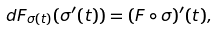Convert formula to latex. <formula><loc_0><loc_0><loc_500><loc_500>d F _ { \sigma ( t ) } ( \sigma ^ { \prime } ( t ) ) = ( F \circ \sigma ) ^ { \prime } ( t ) ,</formula> 